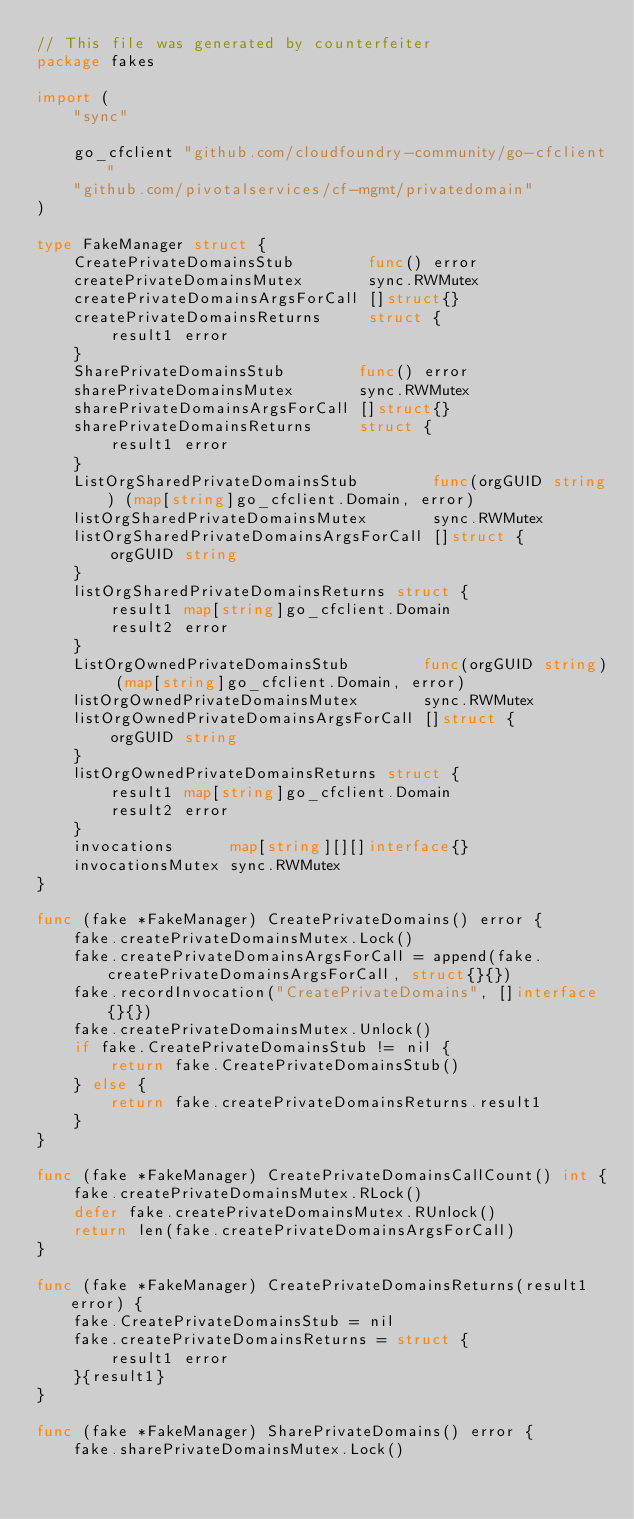Convert code to text. <code><loc_0><loc_0><loc_500><loc_500><_Go_>// This file was generated by counterfeiter
package fakes

import (
	"sync"

	go_cfclient "github.com/cloudfoundry-community/go-cfclient"
	"github.com/pivotalservices/cf-mgmt/privatedomain"
)

type FakeManager struct {
	CreatePrivateDomainsStub        func() error
	createPrivateDomainsMutex       sync.RWMutex
	createPrivateDomainsArgsForCall []struct{}
	createPrivateDomainsReturns     struct {
		result1 error
	}
	SharePrivateDomainsStub        func() error
	sharePrivateDomainsMutex       sync.RWMutex
	sharePrivateDomainsArgsForCall []struct{}
	sharePrivateDomainsReturns     struct {
		result1 error
	}
	ListOrgSharedPrivateDomainsStub        func(orgGUID string) (map[string]go_cfclient.Domain, error)
	listOrgSharedPrivateDomainsMutex       sync.RWMutex
	listOrgSharedPrivateDomainsArgsForCall []struct {
		orgGUID string
	}
	listOrgSharedPrivateDomainsReturns struct {
		result1 map[string]go_cfclient.Domain
		result2 error
	}
	ListOrgOwnedPrivateDomainsStub        func(orgGUID string) (map[string]go_cfclient.Domain, error)
	listOrgOwnedPrivateDomainsMutex       sync.RWMutex
	listOrgOwnedPrivateDomainsArgsForCall []struct {
		orgGUID string
	}
	listOrgOwnedPrivateDomainsReturns struct {
		result1 map[string]go_cfclient.Domain
		result2 error
	}
	invocations      map[string][][]interface{}
	invocationsMutex sync.RWMutex
}

func (fake *FakeManager) CreatePrivateDomains() error {
	fake.createPrivateDomainsMutex.Lock()
	fake.createPrivateDomainsArgsForCall = append(fake.createPrivateDomainsArgsForCall, struct{}{})
	fake.recordInvocation("CreatePrivateDomains", []interface{}{})
	fake.createPrivateDomainsMutex.Unlock()
	if fake.CreatePrivateDomainsStub != nil {
		return fake.CreatePrivateDomainsStub()
	} else {
		return fake.createPrivateDomainsReturns.result1
	}
}

func (fake *FakeManager) CreatePrivateDomainsCallCount() int {
	fake.createPrivateDomainsMutex.RLock()
	defer fake.createPrivateDomainsMutex.RUnlock()
	return len(fake.createPrivateDomainsArgsForCall)
}

func (fake *FakeManager) CreatePrivateDomainsReturns(result1 error) {
	fake.CreatePrivateDomainsStub = nil
	fake.createPrivateDomainsReturns = struct {
		result1 error
	}{result1}
}

func (fake *FakeManager) SharePrivateDomains() error {
	fake.sharePrivateDomainsMutex.Lock()</code> 